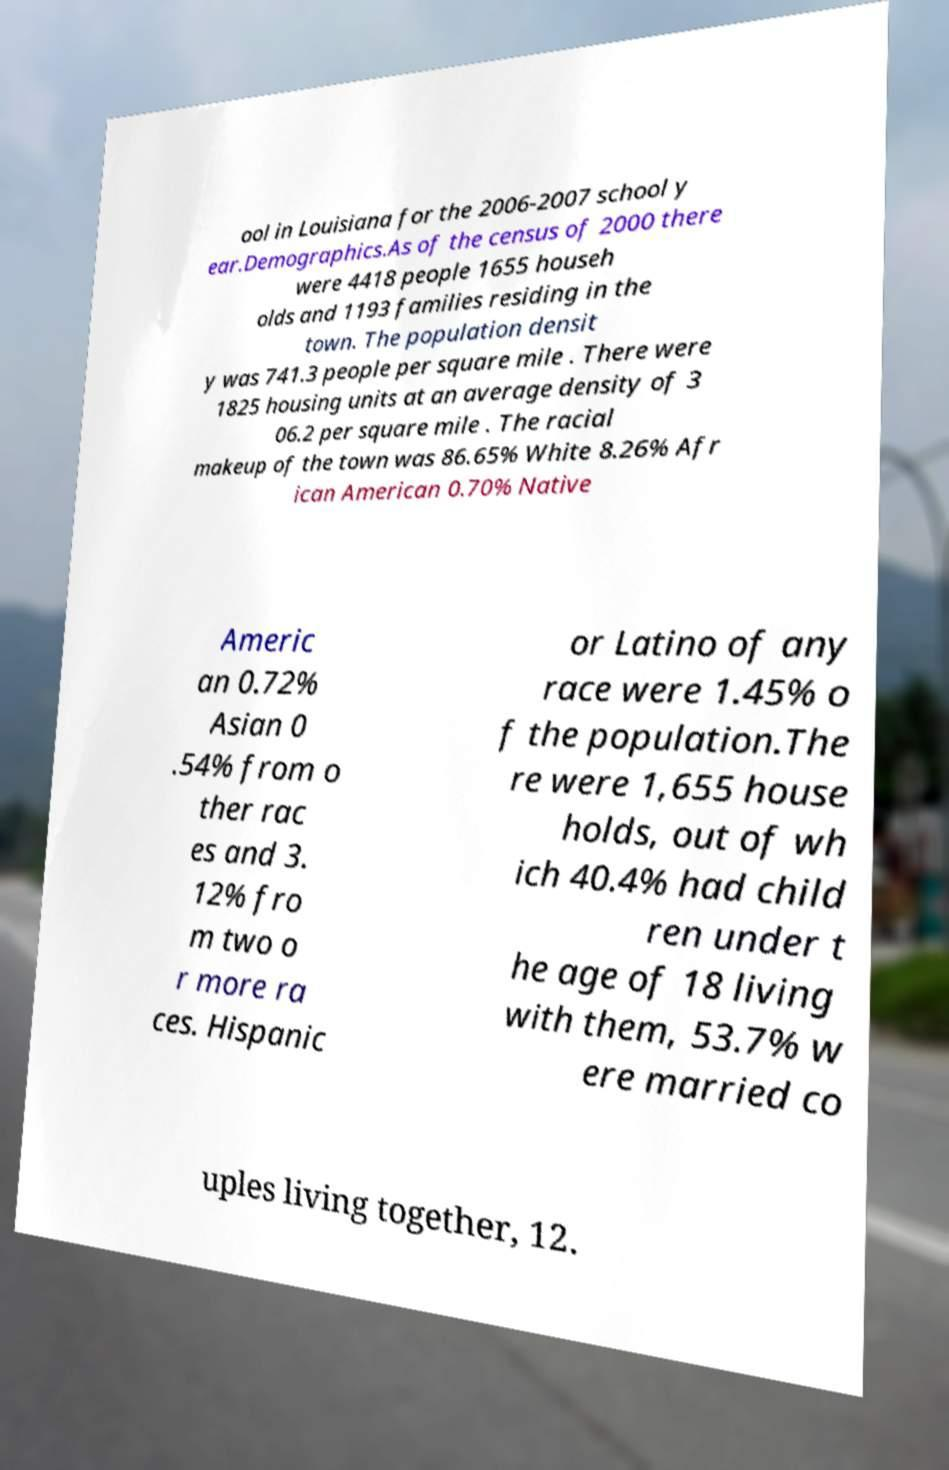Please identify and transcribe the text found in this image. ool in Louisiana for the 2006-2007 school y ear.Demographics.As of the census of 2000 there were 4418 people 1655 househ olds and 1193 families residing in the town. The population densit y was 741.3 people per square mile . There were 1825 housing units at an average density of 3 06.2 per square mile . The racial makeup of the town was 86.65% White 8.26% Afr ican American 0.70% Native Americ an 0.72% Asian 0 .54% from o ther rac es and 3. 12% fro m two o r more ra ces. Hispanic or Latino of any race were 1.45% o f the population.The re were 1,655 house holds, out of wh ich 40.4% had child ren under t he age of 18 living with them, 53.7% w ere married co uples living together, 12. 